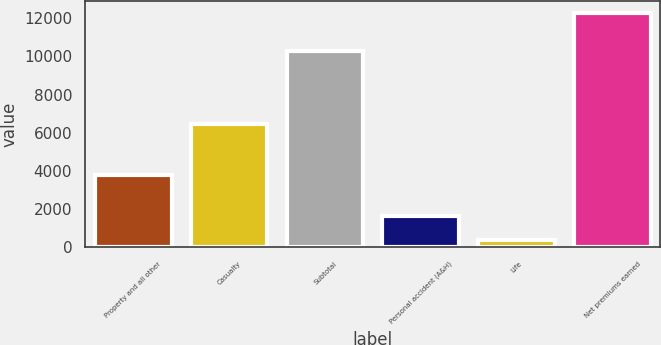Convert chart. <chart><loc_0><loc_0><loc_500><loc_500><bar_chart><fcel>Property and all other<fcel>Casualty<fcel>Subtotal<fcel>Personal accident (A&H)<fcel>Life<fcel>Net premiums earned<nl><fcel>3811<fcel>6464<fcel>10275<fcel>1654<fcel>368<fcel>12297<nl></chart> 